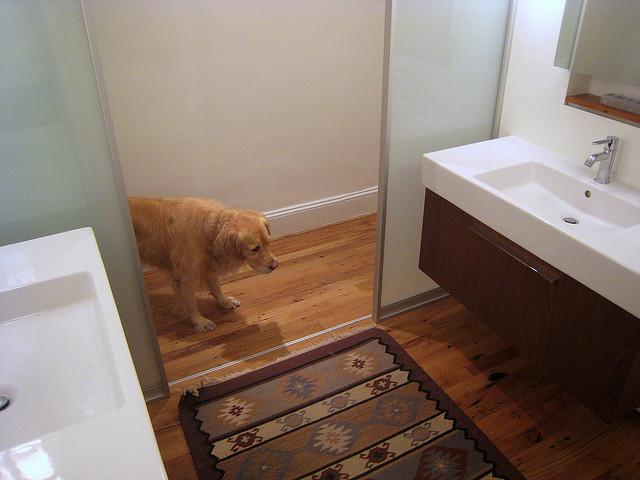What color is the dog standing inside of the doorway to the bathroom? golden 